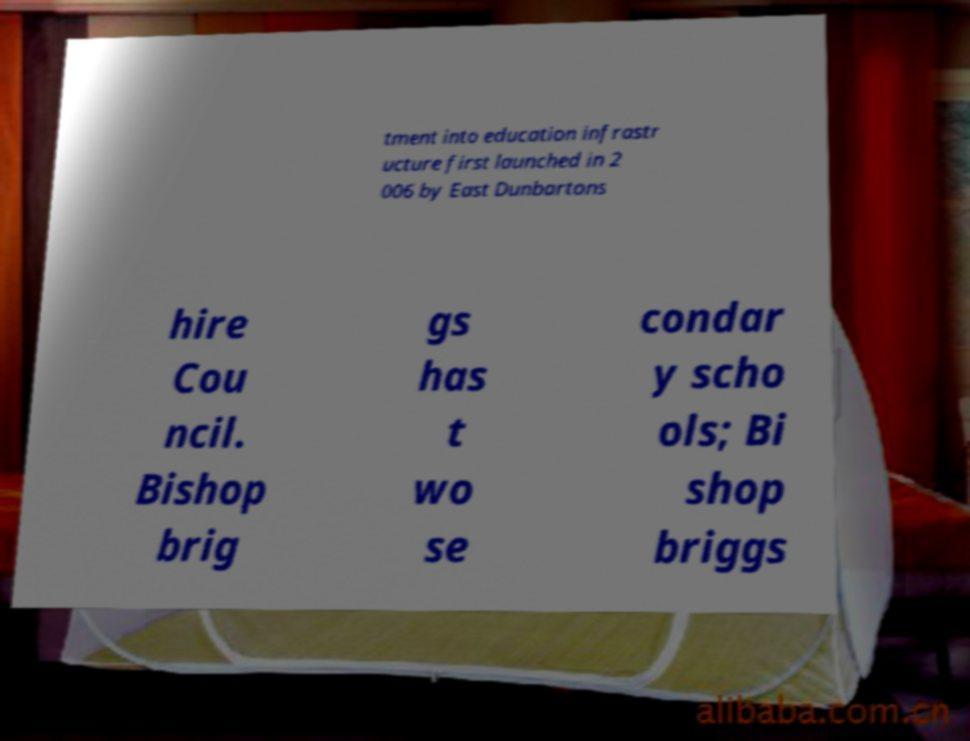What messages or text are displayed in this image? I need them in a readable, typed format. tment into education infrastr ucture first launched in 2 006 by East Dunbartons hire Cou ncil. Bishop brig gs has t wo se condar y scho ols; Bi shop briggs 